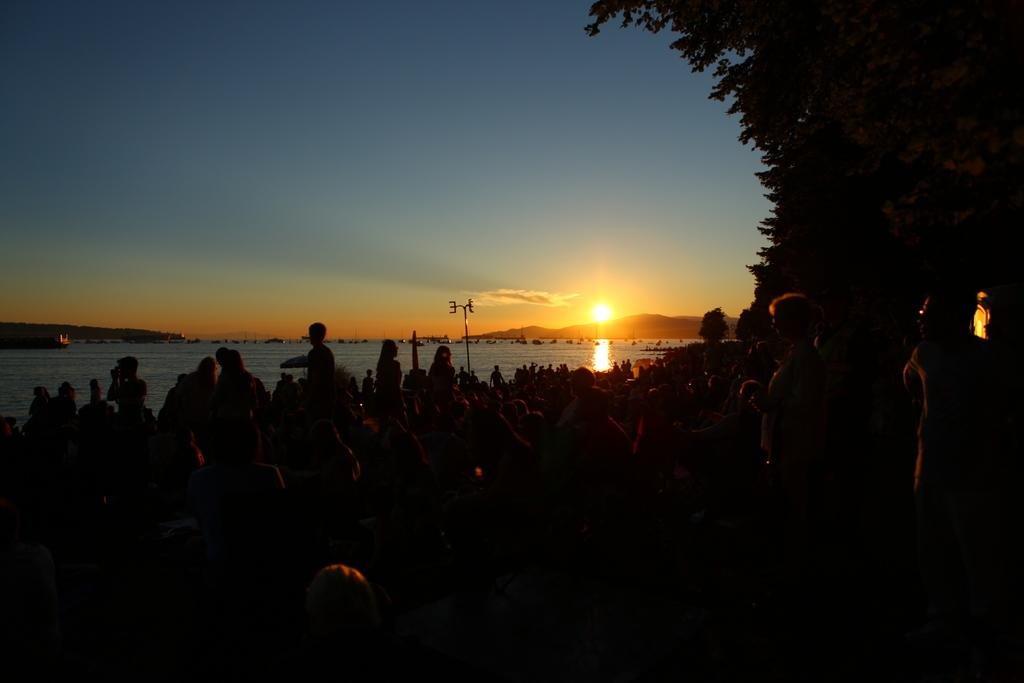What is the color of the bottom part of the image? The bottom of the image is dark. Can you describe the people in the image? There is a group of people in the image. What can be seen in the image besides the people? There is water, a pole, trees, and the sun visible in the image. What is visible in the background of the image? There is sky visible in the background of the image. What type of coat is the person wearing in the image? There is no person wearing a coat in the image. Is there a rifle visible in the image? No, there is no rifle present in the image. 